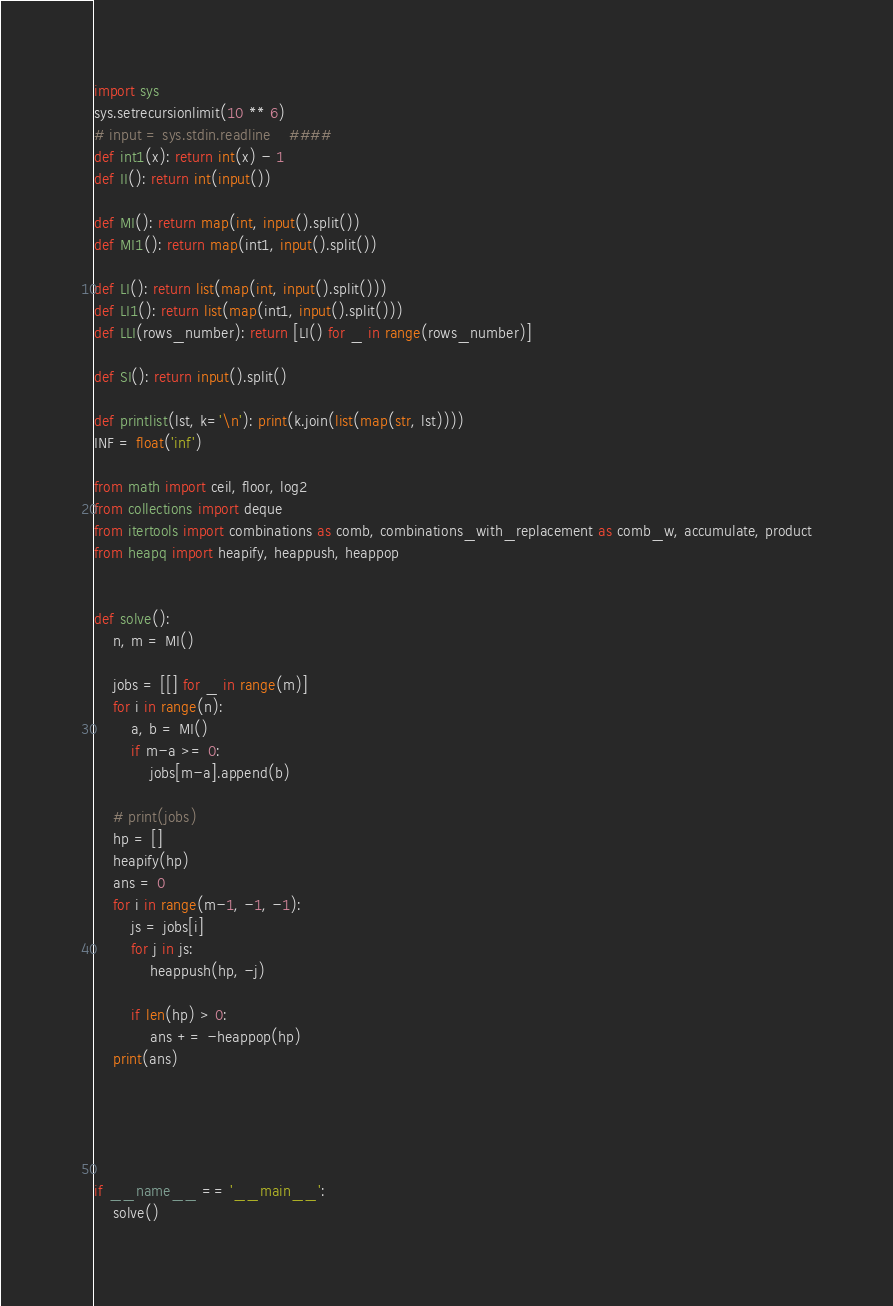Convert code to text. <code><loc_0><loc_0><loc_500><loc_500><_Python_>import sys
sys.setrecursionlimit(10 ** 6)
# input = sys.stdin.readline    ####
def int1(x): return int(x) - 1
def II(): return int(input())

def MI(): return map(int, input().split())
def MI1(): return map(int1, input().split())

def LI(): return list(map(int, input().split()))
def LI1(): return list(map(int1, input().split()))
def LLI(rows_number): return [LI() for _ in range(rows_number)]

def SI(): return input().split()

def printlist(lst, k='\n'): print(k.join(list(map(str, lst))))
INF = float('inf')

from math import ceil, floor, log2
from collections import deque
from itertools import combinations as comb, combinations_with_replacement as comb_w, accumulate, product
from heapq import heapify, heappush, heappop


def solve():
    n, m = MI()

    jobs = [[] for _ in range(m)]
    for i in range(n):
        a, b = MI()
        if m-a >= 0:
            jobs[m-a].append(b)

    # print(jobs)
    hp = []
    heapify(hp)
    ans = 0
    for i in range(m-1, -1, -1):
        js = jobs[i]
        for j in js:
            heappush(hp, -j)

        if len(hp) > 0:
            ans += -heappop(hp)
    print(ans)





if __name__ == '__main__':
    solve()
</code> 